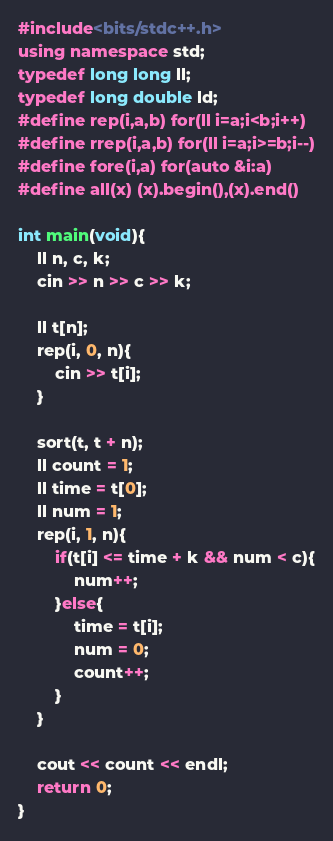<code> <loc_0><loc_0><loc_500><loc_500><_C++_>#include<bits/stdc++.h>
using namespace std;
typedef long long ll;
typedef long double ld;
#define rep(i,a,b) for(ll i=a;i<b;i++)
#define rrep(i,a,b) for(ll i=a;i>=b;i--)
#define fore(i,a) for(auto &i:a)
#define all(x) (x).begin(),(x).end()

int main(void){
    ll n, c, k;
    cin >> n >> c >> k;

    ll t[n];
    rep(i, 0, n){
        cin >> t[i];
    }

    sort(t, t + n);
    ll count = 1;
    ll time = t[0];
    ll num = 1;
    rep(i, 1, n){
        if(t[i] <= time + k && num < c){
            num++;
        }else{
            time = t[i];
            num = 0;
            count++;
        }
    }

    cout << count << endl;
    return 0;
}
</code> 